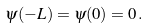<formula> <loc_0><loc_0><loc_500><loc_500>\psi ( - L ) = \psi ( 0 ) = 0 \, .</formula> 